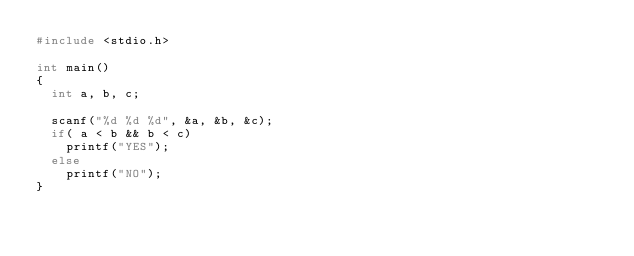<code> <loc_0><loc_0><loc_500><loc_500><_C_>#include <stdio.h>

int main()
{
  int a, b, c;

  scanf("%d %d %d", &a, &b, &c);
  if( a < b && b < c)
    printf("YES");
  else
    printf("NO");
}

</code> 